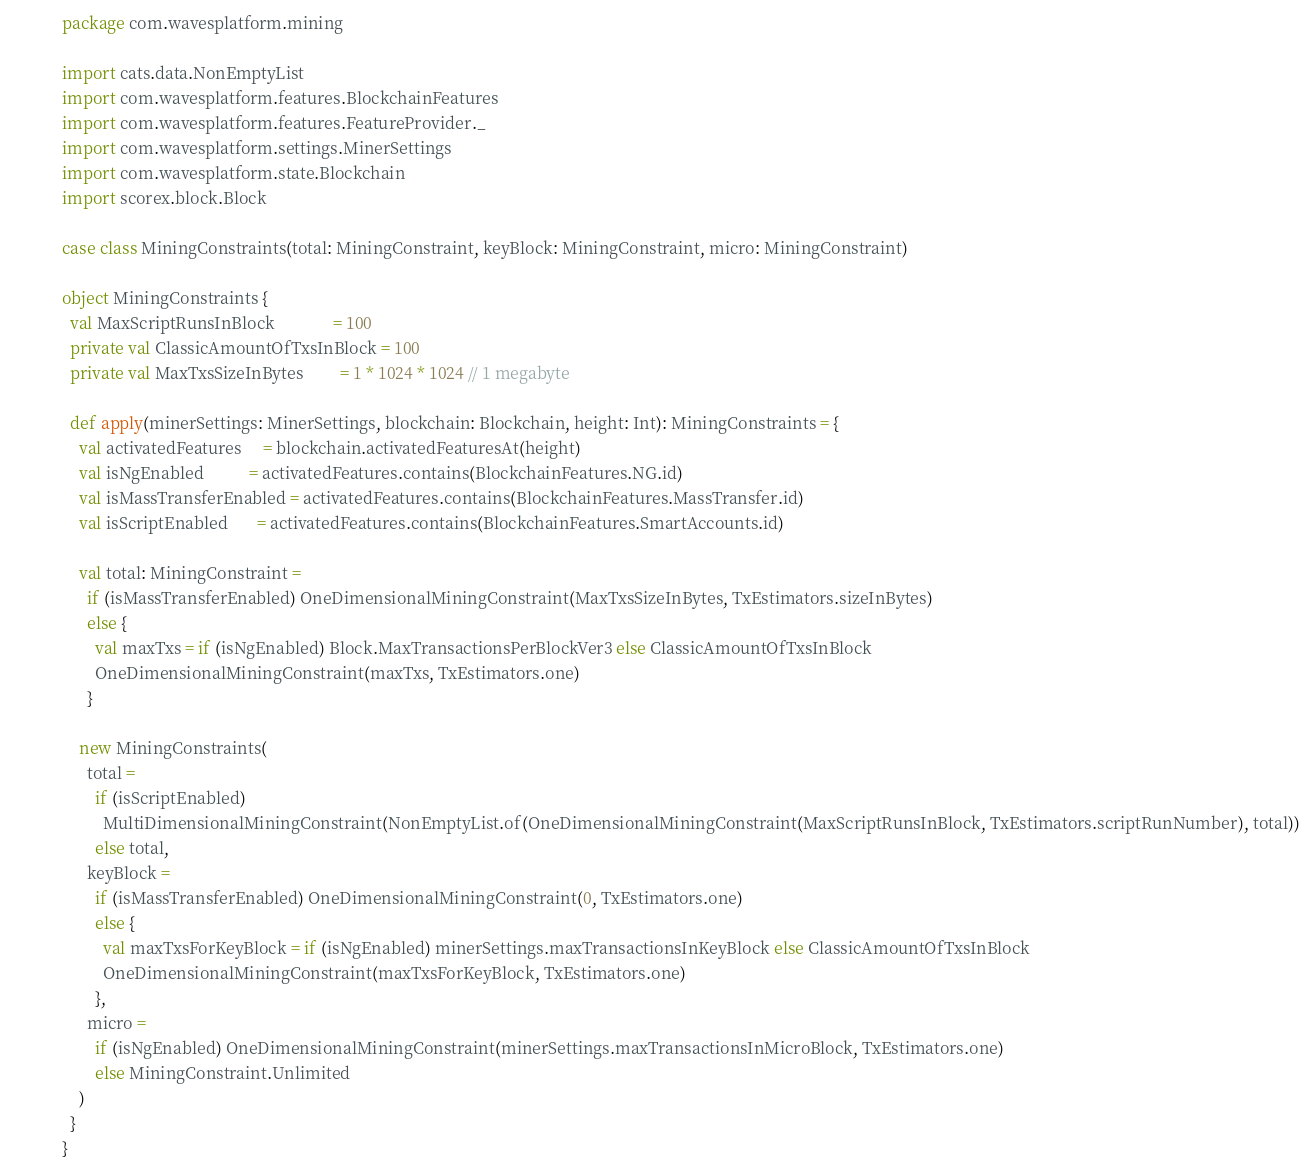<code> <loc_0><loc_0><loc_500><loc_500><_Scala_>package com.wavesplatform.mining

import cats.data.NonEmptyList
import com.wavesplatform.features.BlockchainFeatures
import com.wavesplatform.features.FeatureProvider._
import com.wavesplatform.settings.MinerSettings
import com.wavesplatform.state.Blockchain
import scorex.block.Block

case class MiningConstraints(total: MiningConstraint, keyBlock: MiningConstraint, micro: MiningConstraint)

object MiningConstraints {
  val MaxScriptRunsInBlock              = 100
  private val ClassicAmountOfTxsInBlock = 100
  private val MaxTxsSizeInBytes         = 1 * 1024 * 1024 // 1 megabyte

  def apply(minerSettings: MinerSettings, blockchain: Blockchain, height: Int): MiningConstraints = {
    val activatedFeatures     = blockchain.activatedFeaturesAt(height)
    val isNgEnabled           = activatedFeatures.contains(BlockchainFeatures.NG.id)
    val isMassTransferEnabled = activatedFeatures.contains(BlockchainFeatures.MassTransfer.id)
    val isScriptEnabled       = activatedFeatures.contains(BlockchainFeatures.SmartAccounts.id)

    val total: MiningConstraint =
      if (isMassTransferEnabled) OneDimensionalMiningConstraint(MaxTxsSizeInBytes, TxEstimators.sizeInBytes)
      else {
        val maxTxs = if (isNgEnabled) Block.MaxTransactionsPerBlockVer3 else ClassicAmountOfTxsInBlock
        OneDimensionalMiningConstraint(maxTxs, TxEstimators.one)
      }

    new MiningConstraints(
      total =
        if (isScriptEnabled)
          MultiDimensionalMiningConstraint(NonEmptyList.of(OneDimensionalMiningConstraint(MaxScriptRunsInBlock, TxEstimators.scriptRunNumber), total))
        else total,
      keyBlock =
        if (isMassTransferEnabled) OneDimensionalMiningConstraint(0, TxEstimators.one)
        else {
          val maxTxsForKeyBlock = if (isNgEnabled) minerSettings.maxTransactionsInKeyBlock else ClassicAmountOfTxsInBlock
          OneDimensionalMiningConstraint(maxTxsForKeyBlock, TxEstimators.one)
        },
      micro =
        if (isNgEnabled) OneDimensionalMiningConstraint(minerSettings.maxTransactionsInMicroBlock, TxEstimators.one)
        else MiningConstraint.Unlimited
    )
  }
}
</code> 